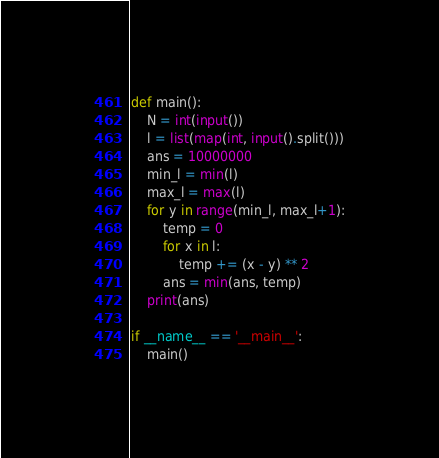Convert code to text. <code><loc_0><loc_0><loc_500><loc_500><_Python_>def main():
    N = int(input())
    l = list(map(int, input().split()))
    ans = 10000000
    min_l = min(l)
    max_l = max(l)
    for y in range(min_l, max_l+1):
        temp = 0
        for x in l:
            temp += (x - y) ** 2
        ans = min(ans, temp)
    print(ans)

if __name__ == '__main__':
    main()</code> 